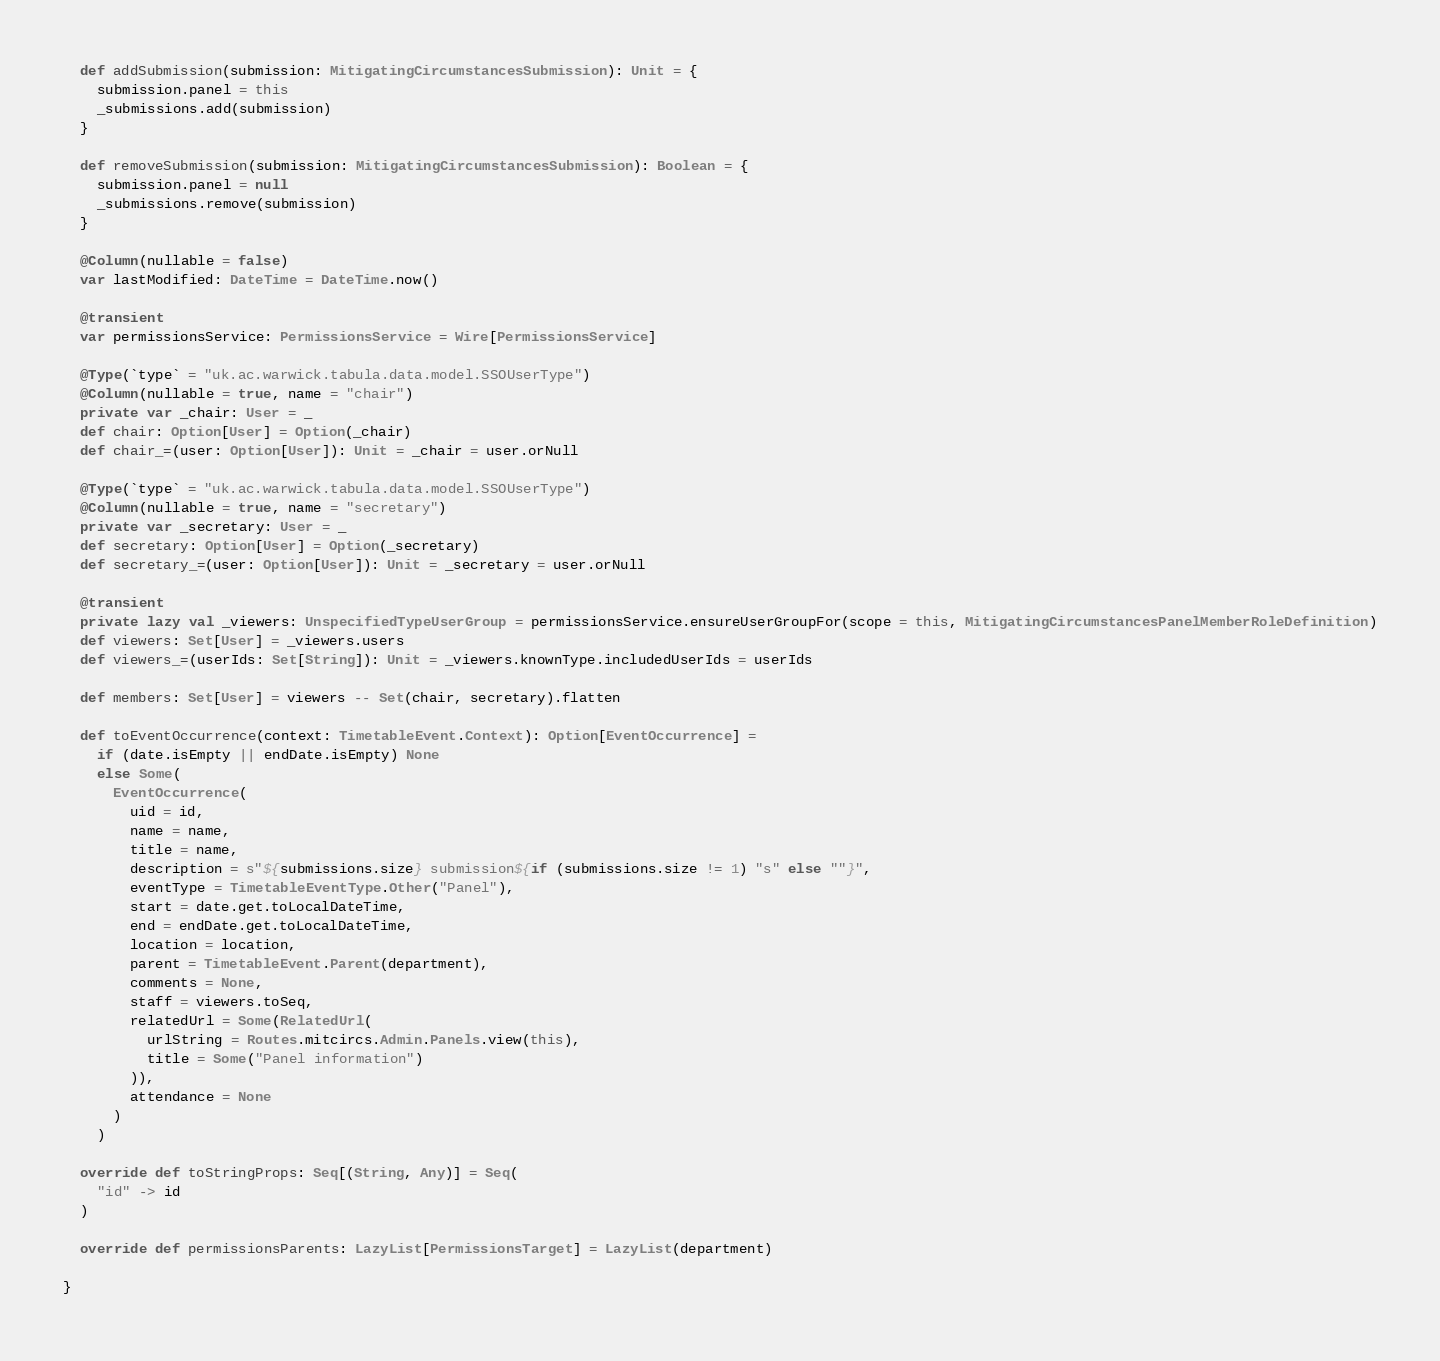Convert code to text. <code><loc_0><loc_0><loc_500><loc_500><_Scala_>  def addSubmission(submission: MitigatingCircumstancesSubmission): Unit = {
    submission.panel = this
    _submissions.add(submission)
  }

  def removeSubmission(submission: MitigatingCircumstancesSubmission): Boolean = {
    submission.panel = null
    _submissions.remove(submission)
  }

  @Column(nullable = false)
  var lastModified: DateTime = DateTime.now()

  @transient
  var permissionsService: PermissionsService = Wire[PermissionsService]

  @Type(`type` = "uk.ac.warwick.tabula.data.model.SSOUserType")
  @Column(nullable = true, name = "chair")
  private var _chair: User = _
  def chair: Option[User] = Option(_chair)
  def chair_=(user: Option[User]): Unit = _chair = user.orNull

  @Type(`type` = "uk.ac.warwick.tabula.data.model.SSOUserType")
  @Column(nullable = true, name = "secretary")
  private var _secretary: User = _
  def secretary: Option[User] = Option(_secretary)
  def secretary_=(user: Option[User]): Unit = _secretary = user.orNull

  @transient
  private lazy val _viewers: UnspecifiedTypeUserGroup = permissionsService.ensureUserGroupFor(scope = this, MitigatingCircumstancesPanelMemberRoleDefinition)
  def viewers: Set[User] = _viewers.users
  def viewers_=(userIds: Set[String]): Unit = _viewers.knownType.includedUserIds = userIds

  def members: Set[User] = viewers -- Set(chair, secretary).flatten

  def toEventOccurrence(context: TimetableEvent.Context): Option[EventOccurrence] =
    if (date.isEmpty || endDate.isEmpty) None
    else Some(
      EventOccurrence(
        uid = id,
        name = name,
        title = name,
        description = s"${submissions.size} submission${if (submissions.size != 1) "s" else ""}",
        eventType = TimetableEventType.Other("Panel"),
        start = date.get.toLocalDateTime,
        end = endDate.get.toLocalDateTime,
        location = location,
        parent = TimetableEvent.Parent(department),
        comments = None,
        staff = viewers.toSeq,
        relatedUrl = Some(RelatedUrl(
          urlString = Routes.mitcircs.Admin.Panels.view(this),
          title = Some("Panel information")
        )),
        attendance = None
      )
    )

  override def toStringProps: Seq[(String, Any)] = Seq(
    "id" -> id
  )

  override def permissionsParents: LazyList[PermissionsTarget] = LazyList(department)

}
</code> 